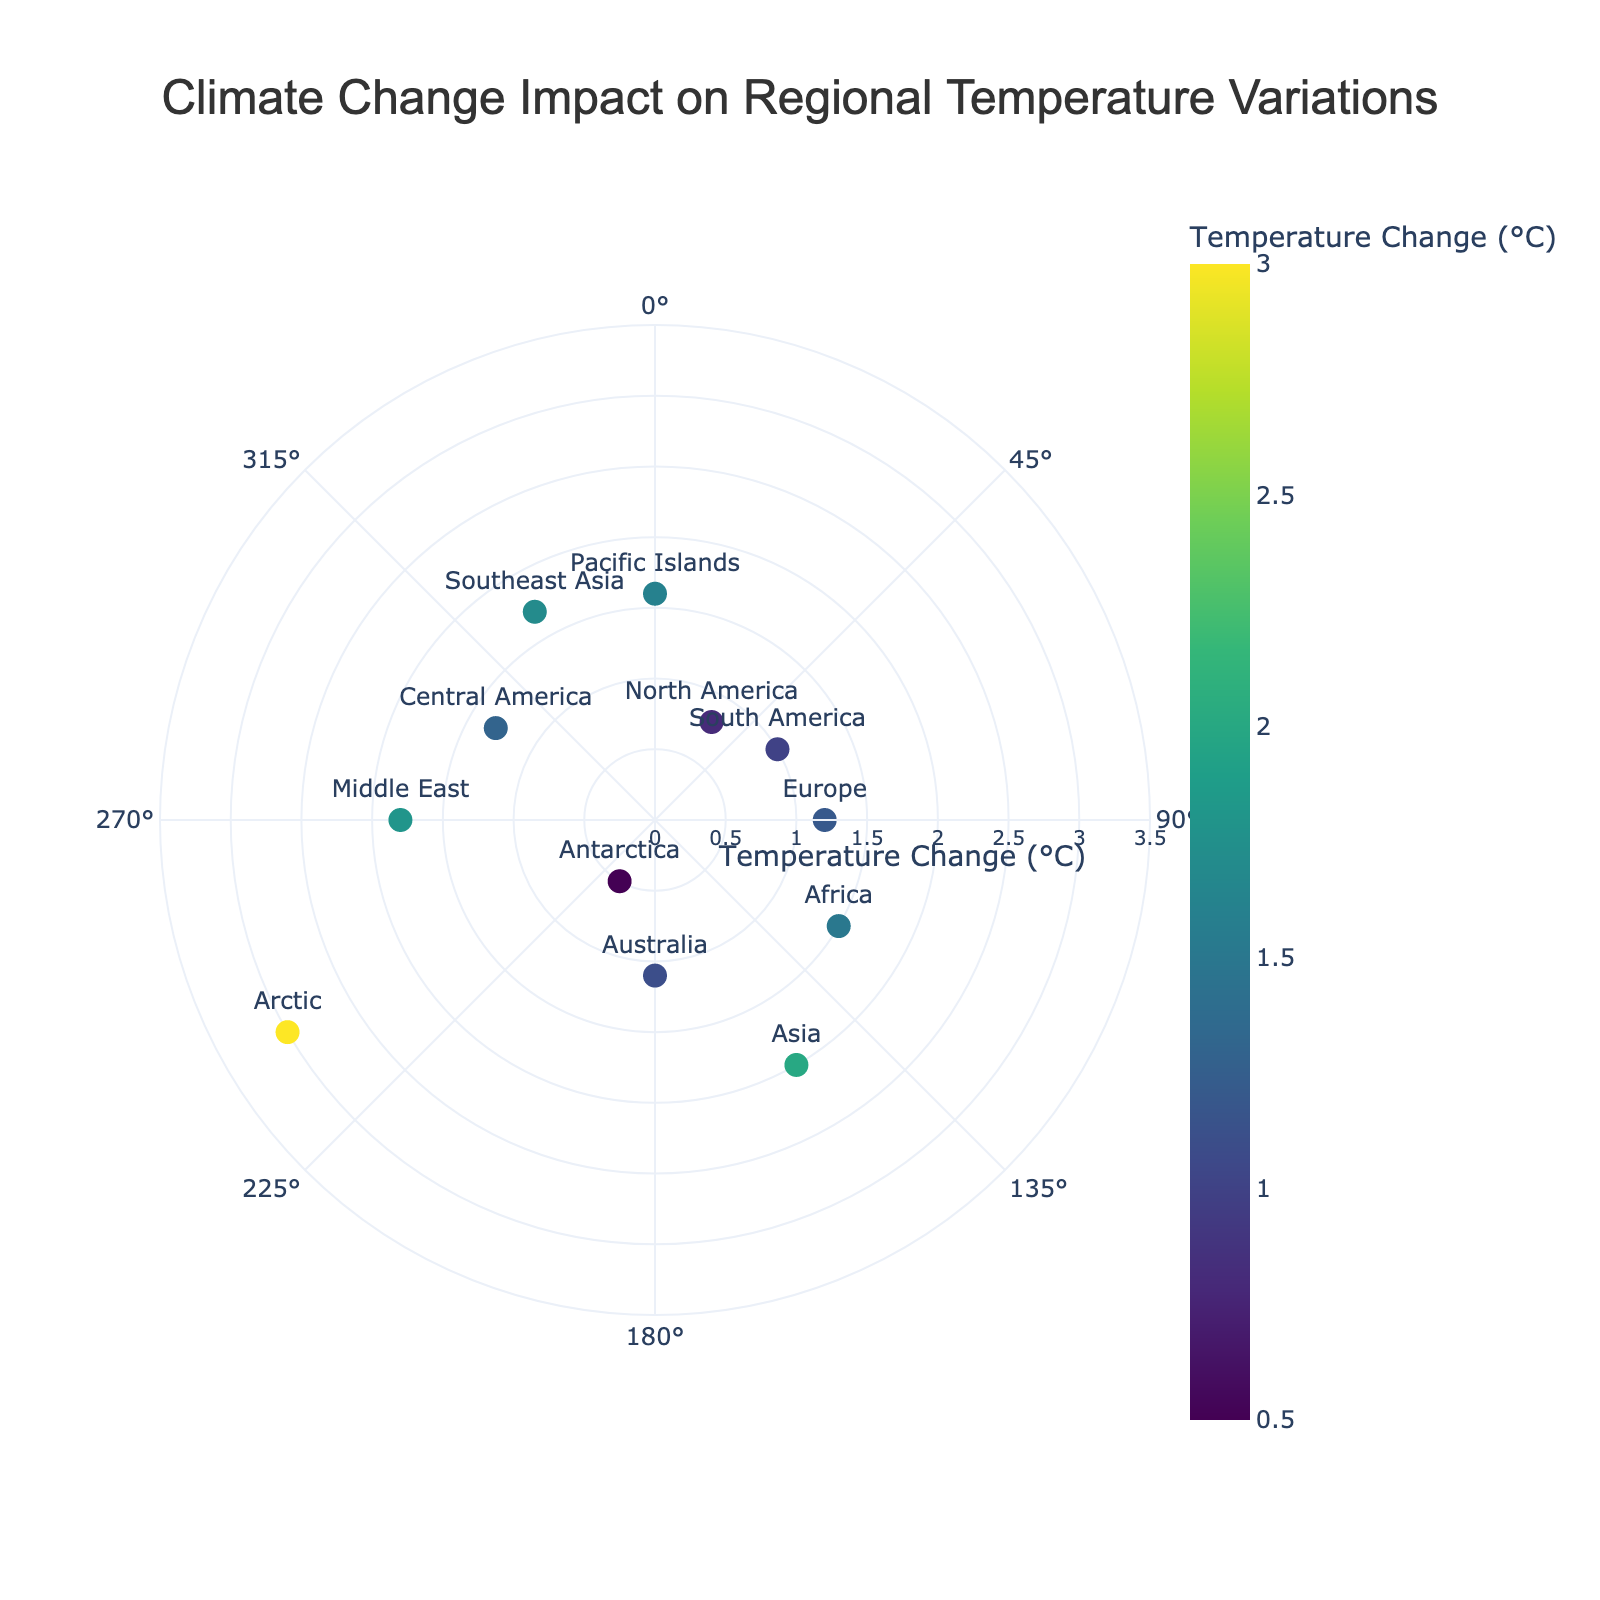What's the title of the figure? The title is placed at the top center of the figure, and it clearly states the subject.
Answer: Climate Change Impact on Regional Temperature Variations How many regions are plotted on the chart? By counting the markers, we can see that each marker represents a region.
Answer: 12 Which region shows the highest temperature change? By looking for the marker farthest from the center, we can identify the region with the highest temperature change.
Answer: Arctic What is the temperature change for Africa? Find the marker labeled "Africa" and check its distance from the center, which corresponds to the temperature change.
Answer: 1.5°C Which two regions have the smallest temperature changes, and what are their values? Identify the markers closest to the center and check their corresponding temperature change values.
Answer: Antarctica (0.5°C) and North America (0.8°C) What is the average temperature change across all regions? Sum all the temperature change values and divide by the number of regions (12). Sum = (0.8 + 1.0 + 1.2 + 1.5 + 2.0 + 1.1 + 0.5 + 3.0 + 1.8 + 1.3 + 1.7 + 1.6) = 17.5, so the average is 17.5/12 ≈ 1.46
Answer: 1.46°C Which regions have a temperature change greater than 1.5°C? Check the temperature change values and list the regions with values greater than 1.5°C.
Answer: Arctic, Asia, Middle East, Southeast Asia, Pacific Islands Is the temperature change for Europe higher or lower than the average temperature change? Compare the temperature change for Europe with the average temperature change calculated previously.
Answer: Higher What angle is used to represent Asia and what is its temperature change? Find the marker for Asia, note its angle, and check its distance from the center.
Answer: 150 degrees, 2.0°C Which regions have a temperature change between 1.0°C and 2.0°C? Look for markers with distances from the center within this range and list the corresponding regions.
Answer: South America, Europe, Australia, Middle East, Central America, Southeast Asia, Pacific Islands 